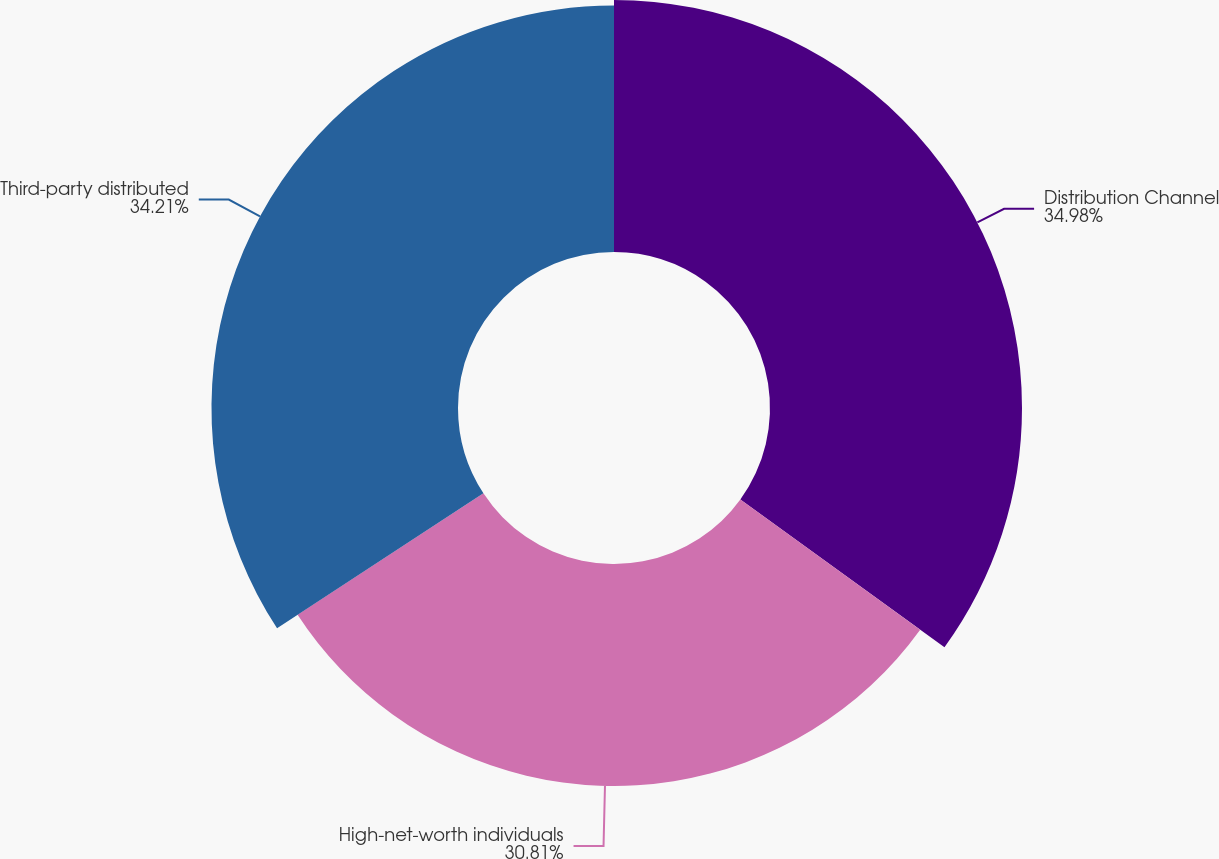Convert chart to OTSL. <chart><loc_0><loc_0><loc_500><loc_500><pie_chart><fcel>Distribution Channel<fcel>High-net-worth individuals<fcel>Third-party distributed<nl><fcel>34.97%<fcel>30.81%<fcel>34.21%<nl></chart> 